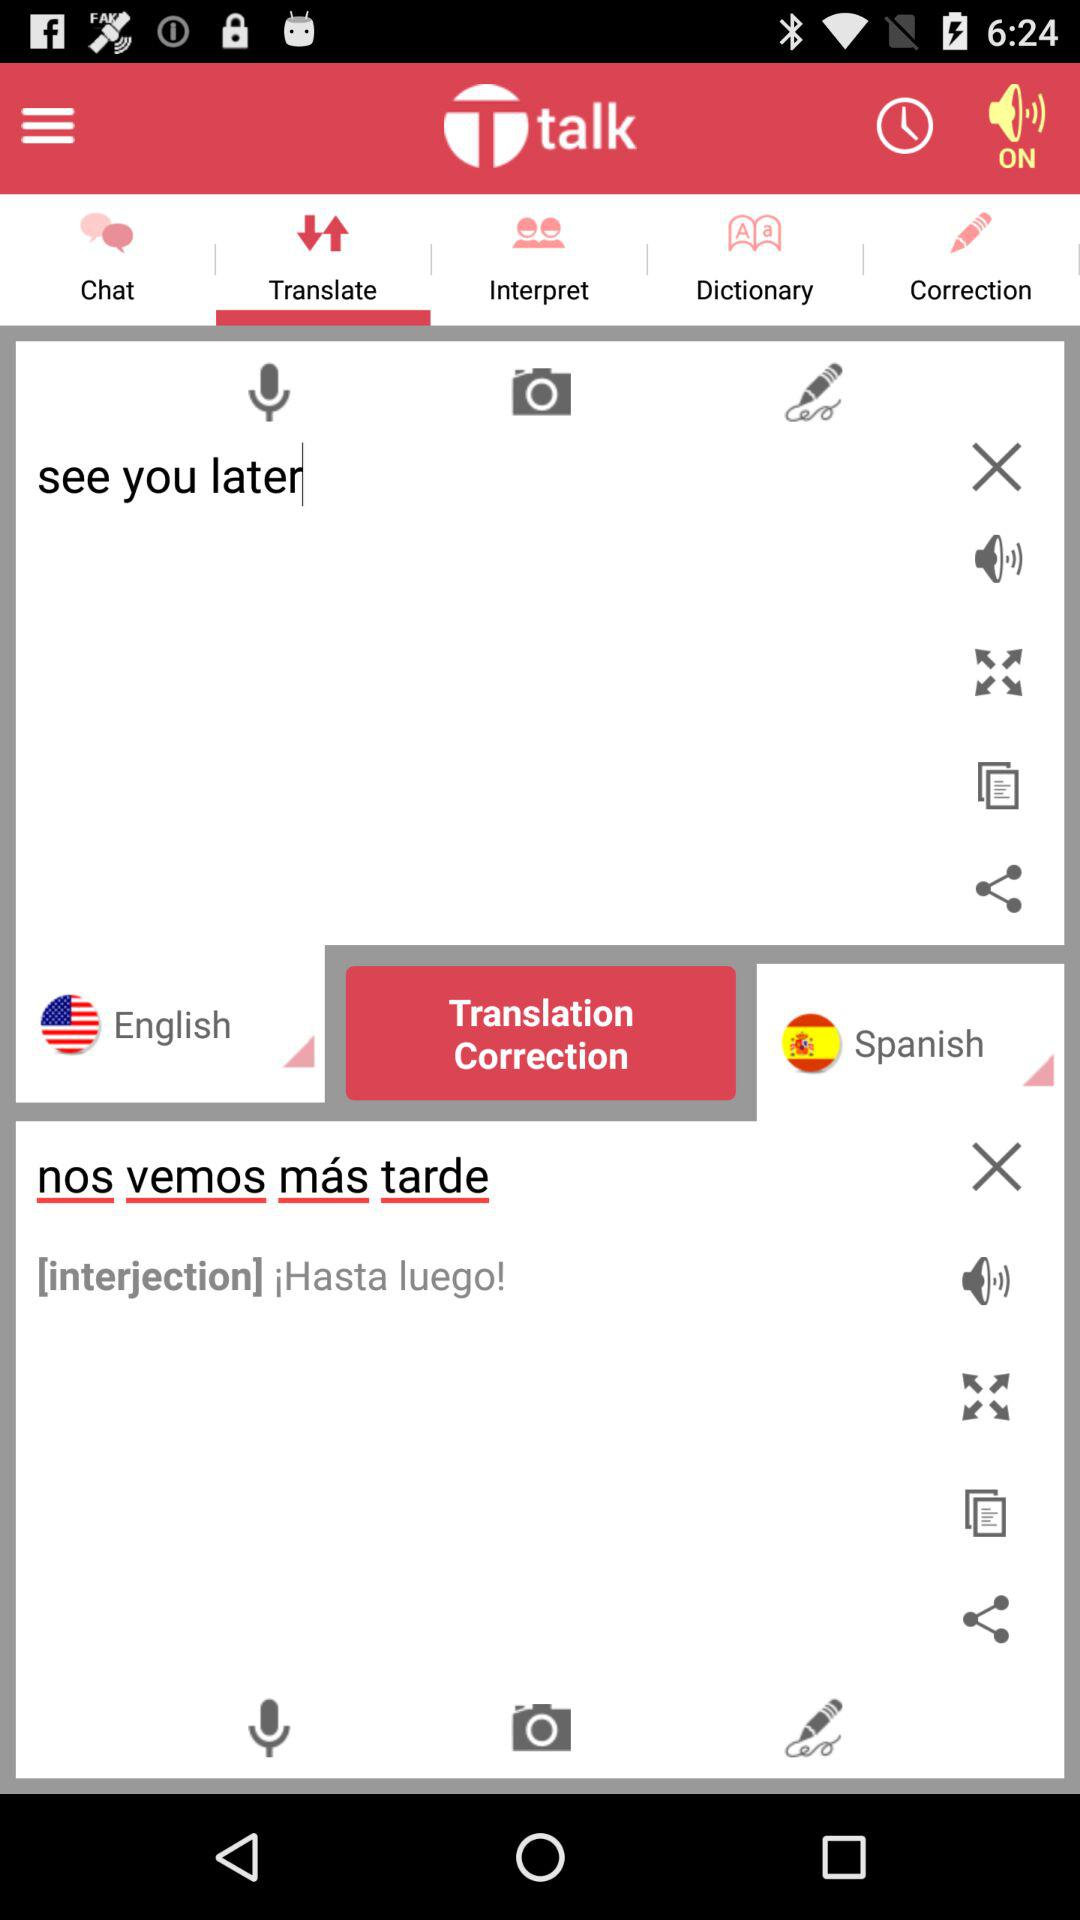Which option is selected? The selected options are "Translate", "English" and "Spanish". 